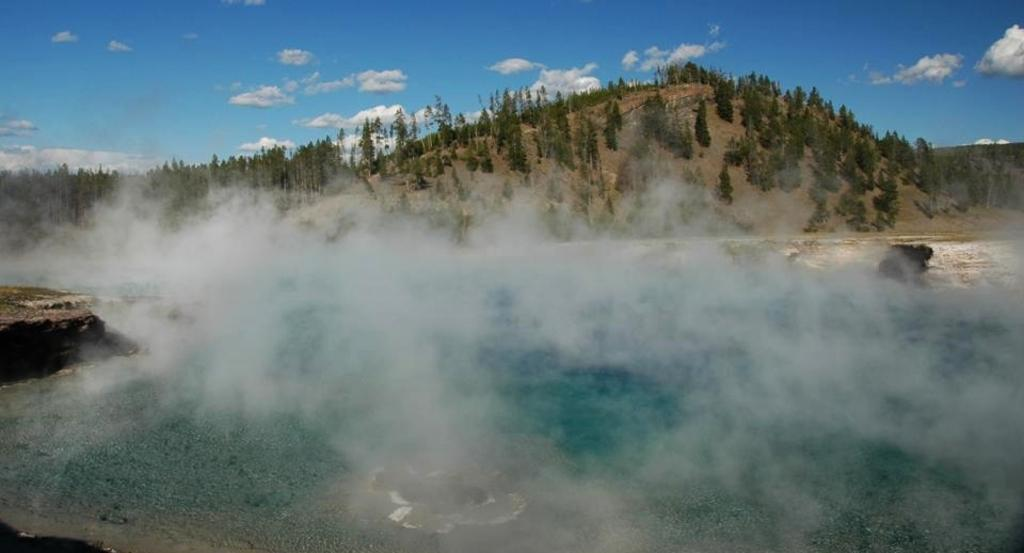What can be seen in the image that is not a solid object? There is smoke in the image. What type of natural landscape is visible in the image? There are trees on a hill in the image. What is visible in the sky in the image? There are clouds in the sky in the image. What type of landform is present at the bottom of the image? There is an island at the bottom of the image. Where is the party taking place in the image? There is no party present in the image. Can you see any friends hanging out on the island in the image? There are no people, including friends, visible in the image. 